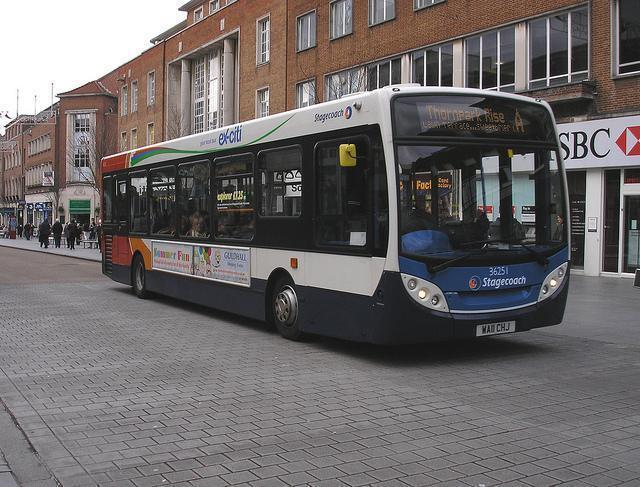How many levels on the bus?
Give a very brief answer. 1. How many buses are there?
Give a very brief answer. 1. How many busses?
Give a very brief answer. 1. 